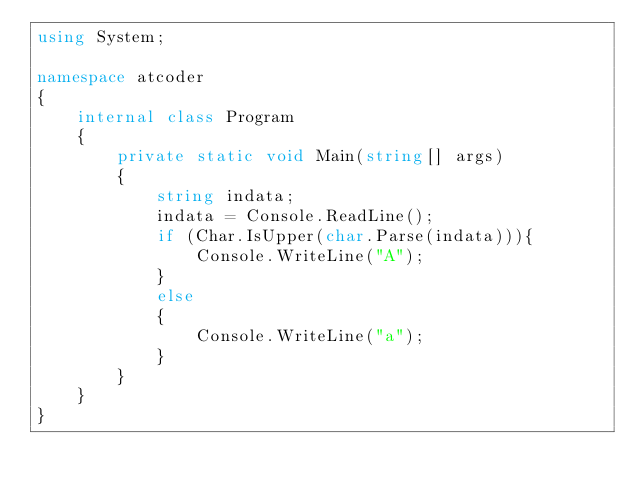<code> <loc_0><loc_0><loc_500><loc_500><_C#_>using System;

namespace atcoder
{
    internal class Program
    {
        private static void Main(string[] args)
        {
            string indata;
            indata = Console.ReadLine();
            if (Char.IsUpper(char.Parse(indata))){
                Console.WriteLine("A");
            }
            else
            {
                Console.WriteLine("a");
            }
        }
    }
}</code> 